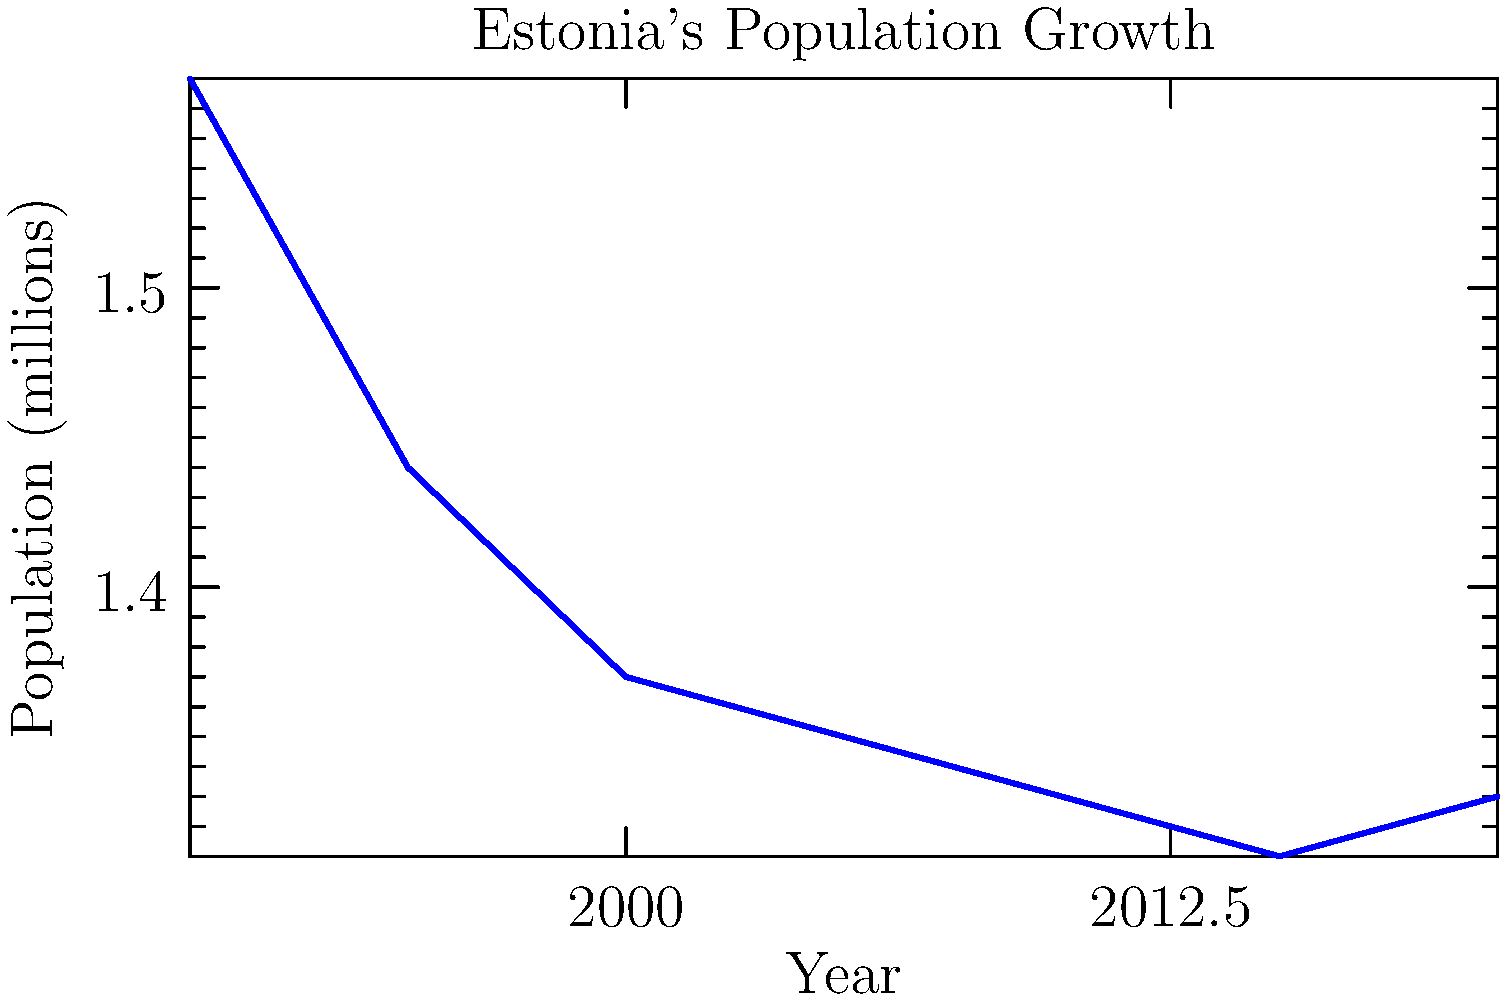Based on the line graph showing Estonia's population from 1990 to 2020, in which period did the population start to increase again after a long decline? To answer this question, we need to follow these steps:

1. Observe the general trend of the graph:
   The line starts high in 1990 and generally decreases until 2015.

2. Look for a turning point:
   After 2015, we can see the line starts to go up slightly.

3. Identify the specific period:
   The increase occurs between 2015 and 2020.

4. Confirm the change:
   The population value at 2015 is lower than the value at 2020, confirming an increase.

Therefore, the period when Estonia's population started to increase again after a long decline was between 2015 and 2020.
Answer: 2015-2020 